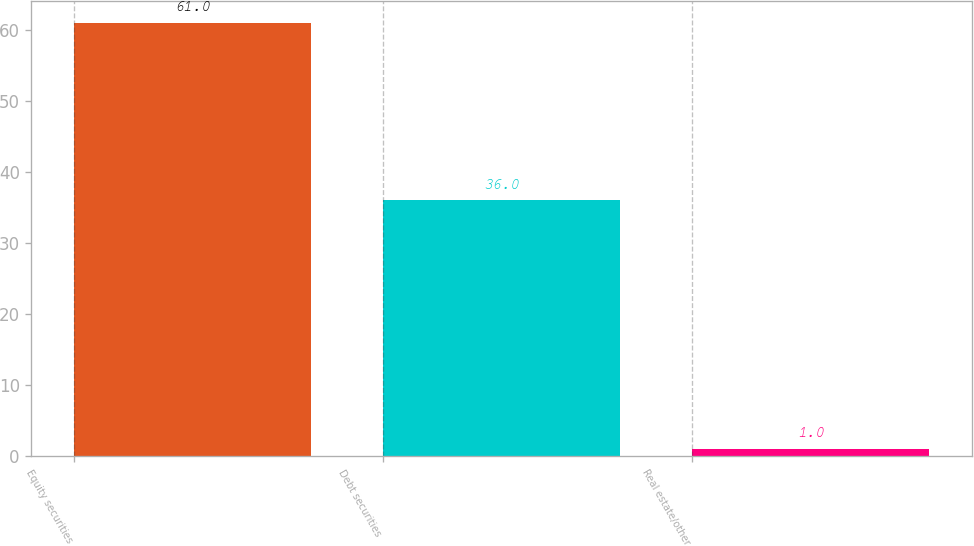<chart> <loc_0><loc_0><loc_500><loc_500><bar_chart><fcel>Equity securities<fcel>Debt securities<fcel>Real estate/other<nl><fcel>61<fcel>36<fcel>1<nl></chart> 